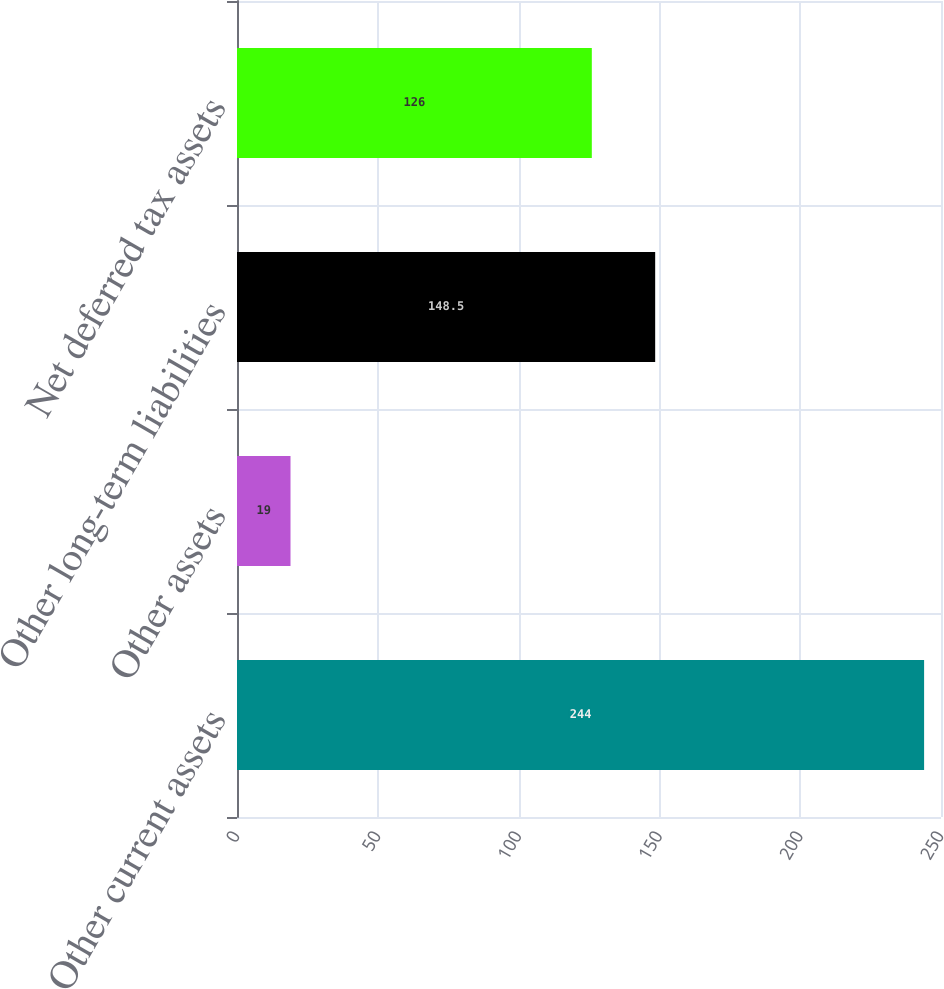Convert chart. <chart><loc_0><loc_0><loc_500><loc_500><bar_chart><fcel>Other current assets<fcel>Other assets<fcel>Other long-term liabilities<fcel>Net deferred tax assets<nl><fcel>244<fcel>19<fcel>148.5<fcel>126<nl></chart> 